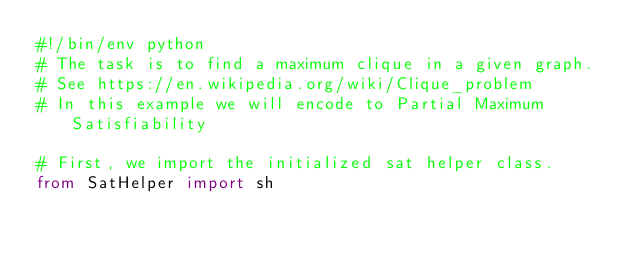Convert code to text. <code><loc_0><loc_0><loc_500><loc_500><_Python_>#!/bin/env python
# The task is to find a maximum clique in a given graph.
# See https://en.wikipedia.org/wiki/Clique_problem
# In this example we will encode to Partial Maximum Satisfiability

# First, we import the initialized sat helper class.
from SatHelper import sh</code> 